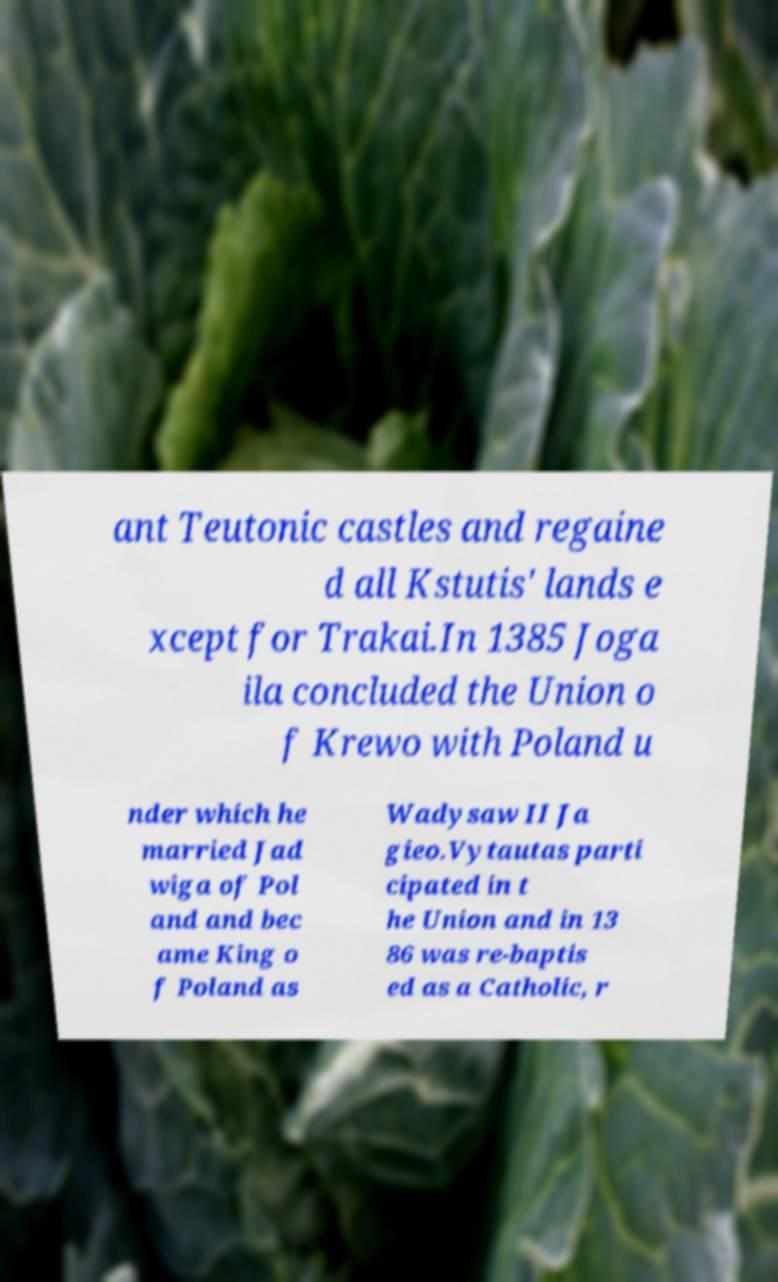Could you assist in decoding the text presented in this image and type it out clearly? ant Teutonic castles and regaine d all Kstutis' lands e xcept for Trakai.In 1385 Joga ila concluded the Union o f Krewo with Poland u nder which he married Jad wiga of Pol and and bec ame King o f Poland as Wadysaw II Ja gieo.Vytautas parti cipated in t he Union and in 13 86 was re-baptis ed as a Catholic, r 